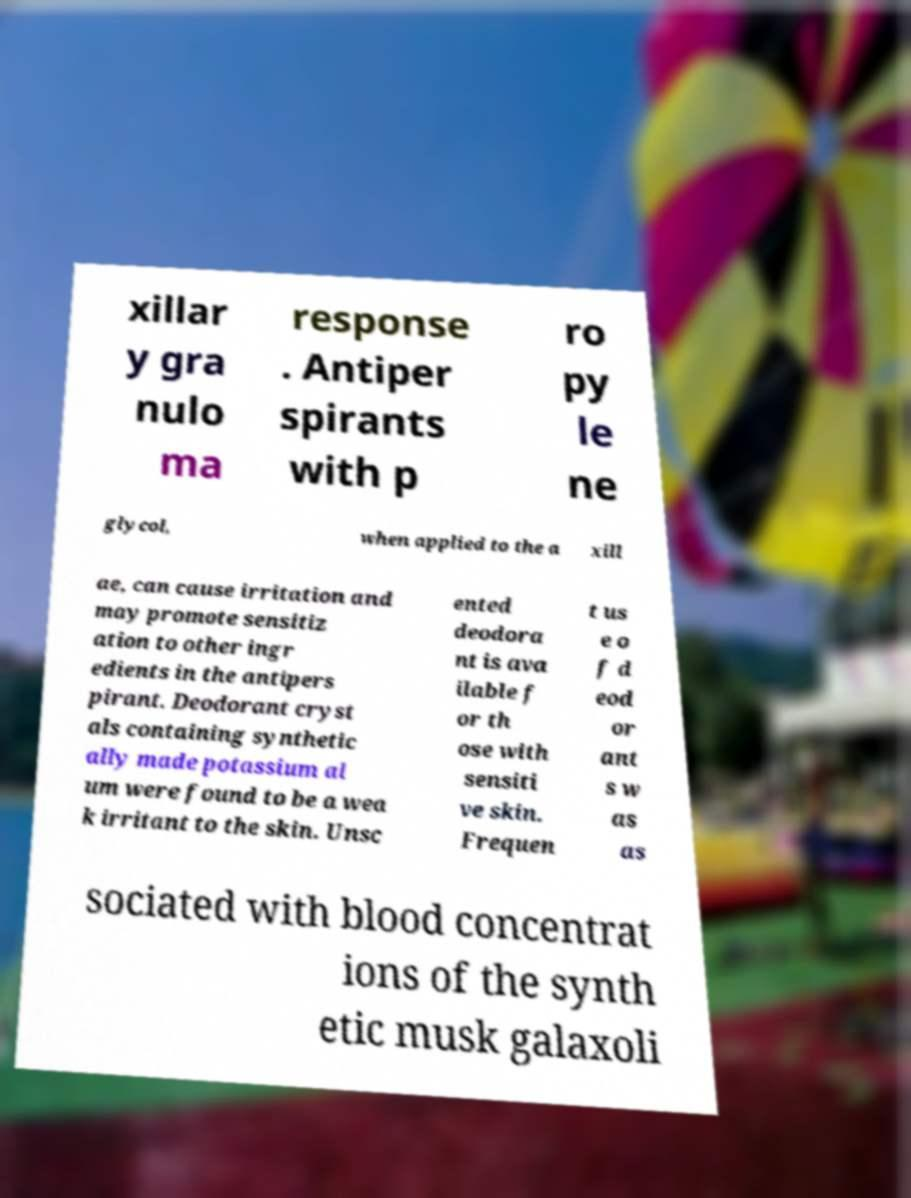There's text embedded in this image that I need extracted. Can you transcribe it verbatim? xillar y gra nulo ma response . Antiper spirants with p ro py le ne glycol, when applied to the a xill ae, can cause irritation and may promote sensitiz ation to other ingr edients in the antipers pirant. Deodorant cryst als containing synthetic ally made potassium al um were found to be a wea k irritant to the skin. Unsc ented deodora nt is ava ilable f or th ose with sensiti ve skin. Frequen t us e o f d eod or ant s w as as sociated with blood concentrat ions of the synth etic musk galaxoli 